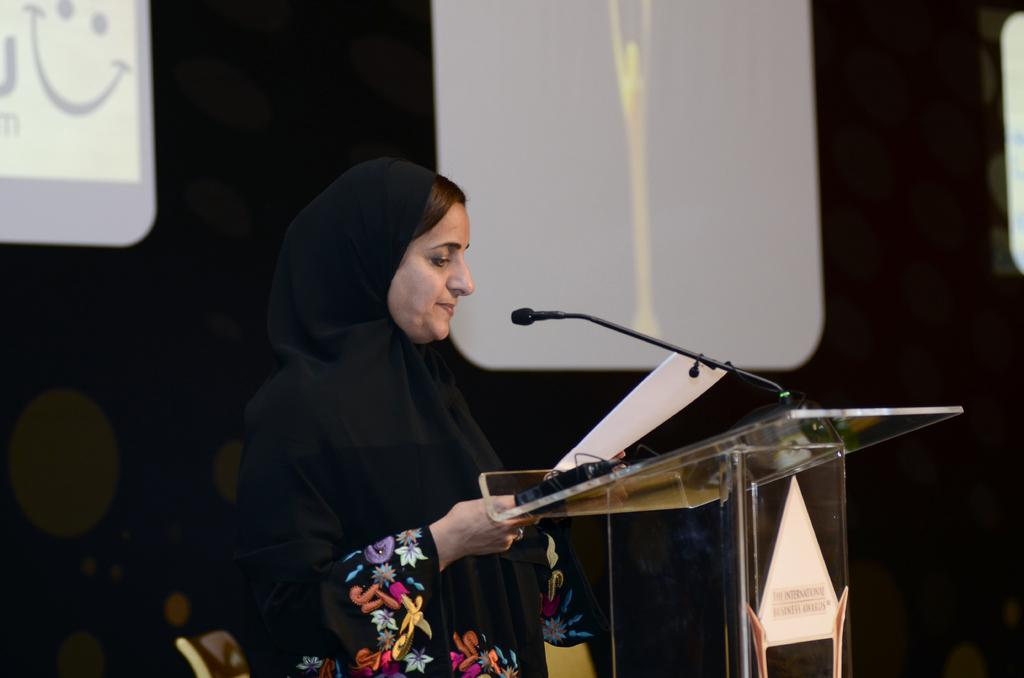What is the person in the image doing? The person is holding a paper and standing near a podium. What object might the person be using to communicate with others? There is a microphone in the image, which the person might be using to communicate. What is the person standing near? The person is standing near a podium. What type of furniture is present in the image? There is a chair in the image. What can be seen in the background of the image? There is a screen in the background of the image. What force is being applied to the person's legs in the image? There is no force being applied to the person's legs in the image; they are standing freely. What part of the person's body is missing in the image? There is no indication that any part of the person's body is missing in the image. 